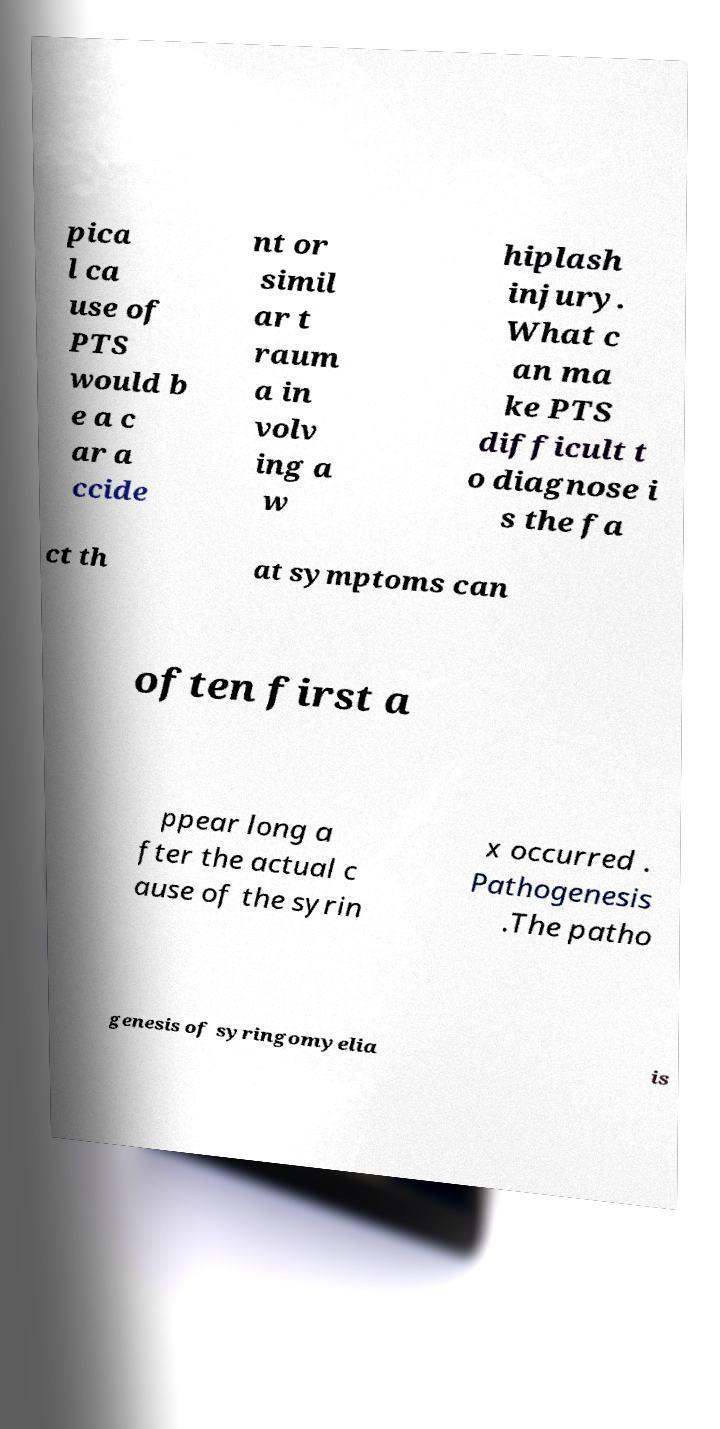Please read and relay the text visible in this image. What does it say? pica l ca use of PTS would b e a c ar a ccide nt or simil ar t raum a in volv ing a w hiplash injury. What c an ma ke PTS difficult t o diagnose i s the fa ct th at symptoms can often first a ppear long a fter the actual c ause of the syrin x occurred . Pathogenesis .The patho genesis of syringomyelia is 